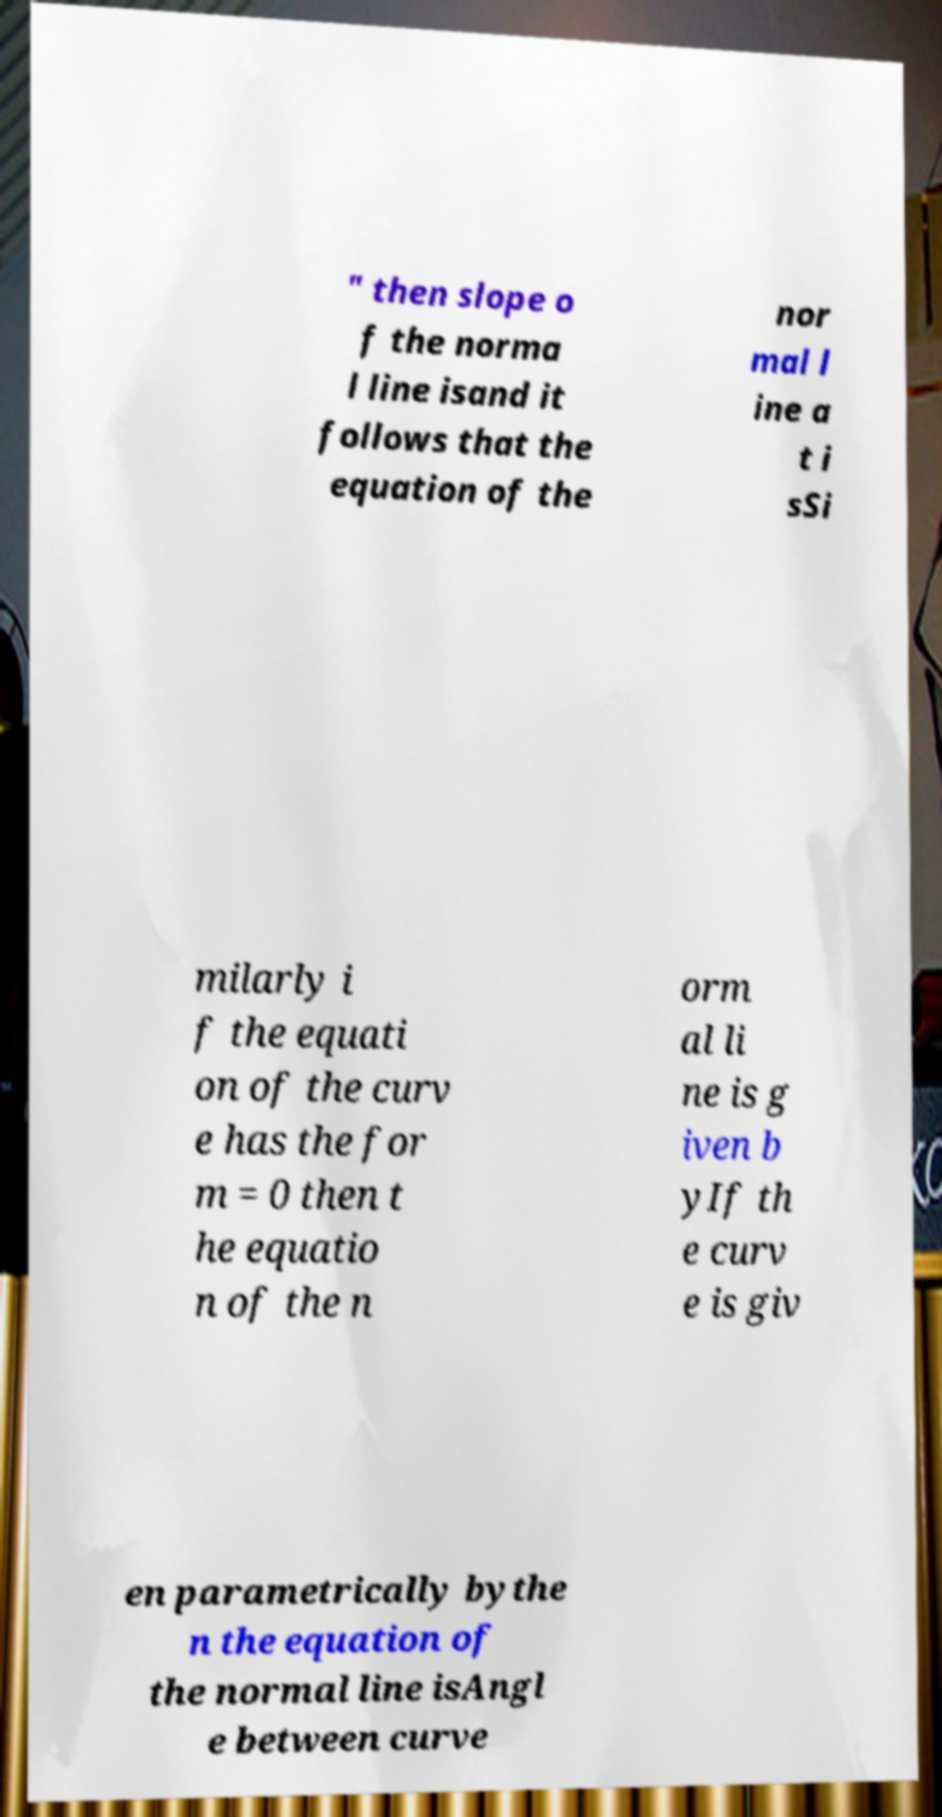What does it mean when a text discusses the equation of a curve 'given parametrically'? When a curve is described as 'given parametrically,' it means the curve is expressed with a set of equations representing the coordinates as functions of a third variable, often t, which is called the parameter. For example, x and y might both be functions of t. This form is typically used for curves that cannot be expressed as functions of x or y alone and can describe more complex shapes and movements. 